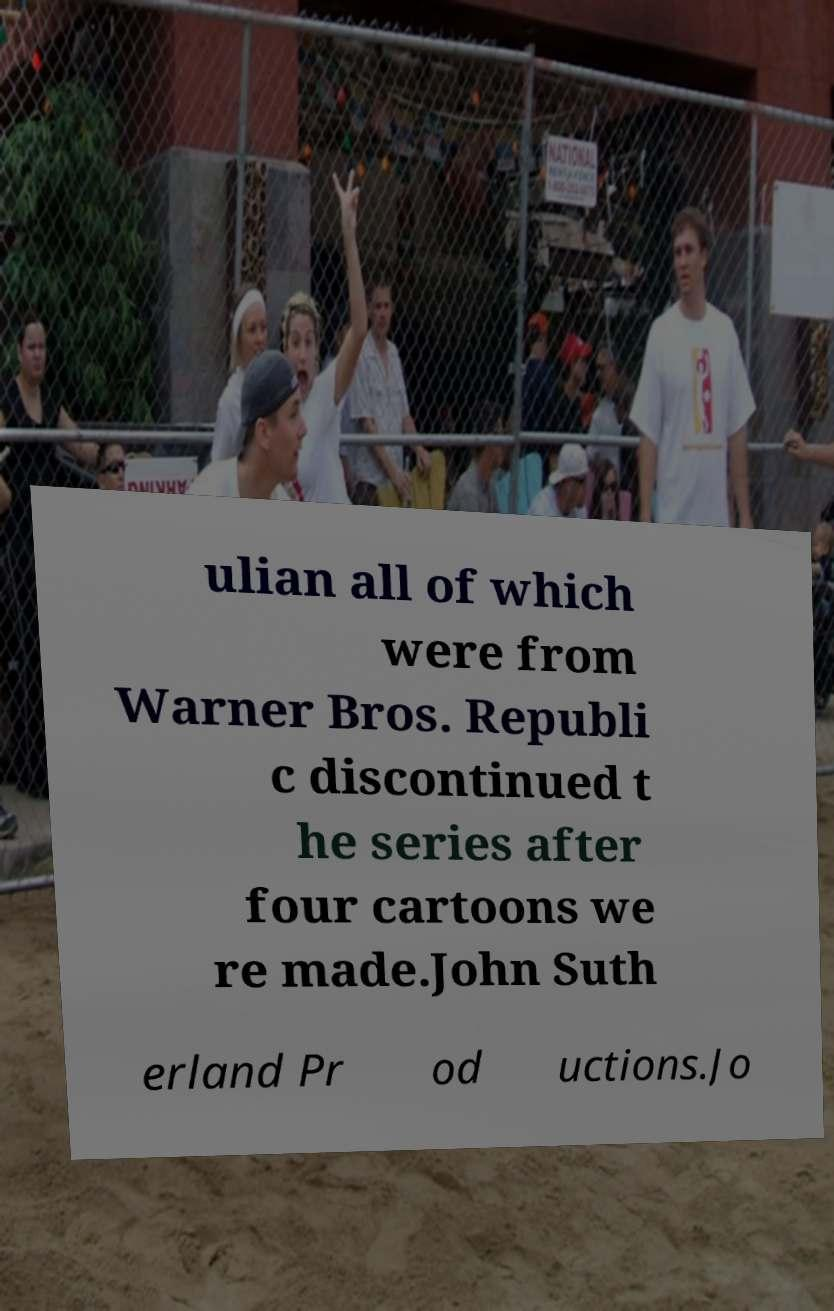Please read and relay the text visible in this image. What does it say? ulian all of which were from Warner Bros. Republi c discontinued t he series after four cartoons we re made.John Suth erland Pr od uctions.Jo 